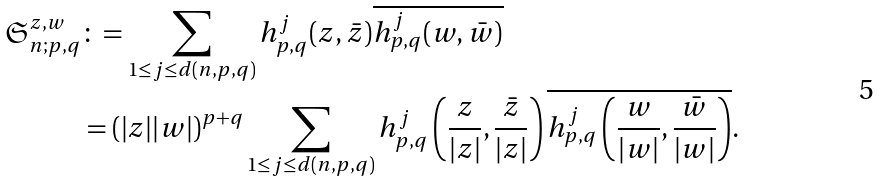Convert formula to latex. <formula><loc_0><loc_0><loc_500><loc_500>\mathfrak { S } _ { n ; p , q } ^ { z , w } & \colon = \sum _ { \substack { 1 \leq j \leq d ( n , p , q ) } } h _ { p , q } ^ { j } ( z , \bar { z } ) \overline { h _ { p , q } ^ { j } ( w , \bar { w } ) } \\ & = \left ( | z | | w | \right ) ^ { p + q } \sum _ { \substack { 1 \leq j \leq d ( n , p , q ) } } h _ { p , q } ^ { j } \left ( \frac { z } { | z | } , \frac { \bar { z } } { | z | } \right ) \overline { h _ { p , q } ^ { j } \left ( \frac { w } { | w | } , \frac { \bar { w } } { | w | } \right ) } .</formula> 